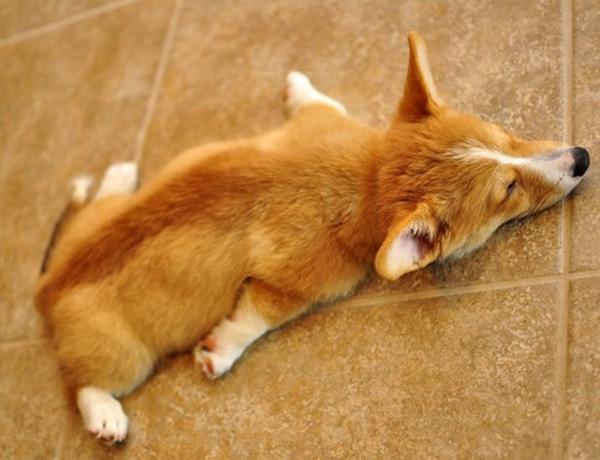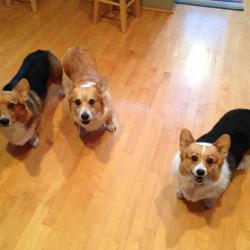The first image is the image on the left, the second image is the image on the right. Assess this claim about the two images: "There are no more than two dogs in the left image.". Correct or not? Answer yes or no. Yes. The first image is the image on the left, the second image is the image on the right. Evaluate the accuracy of this statement regarding the images: "There are at most four dogs.". Is it true? Answer yes or no. Yes. 